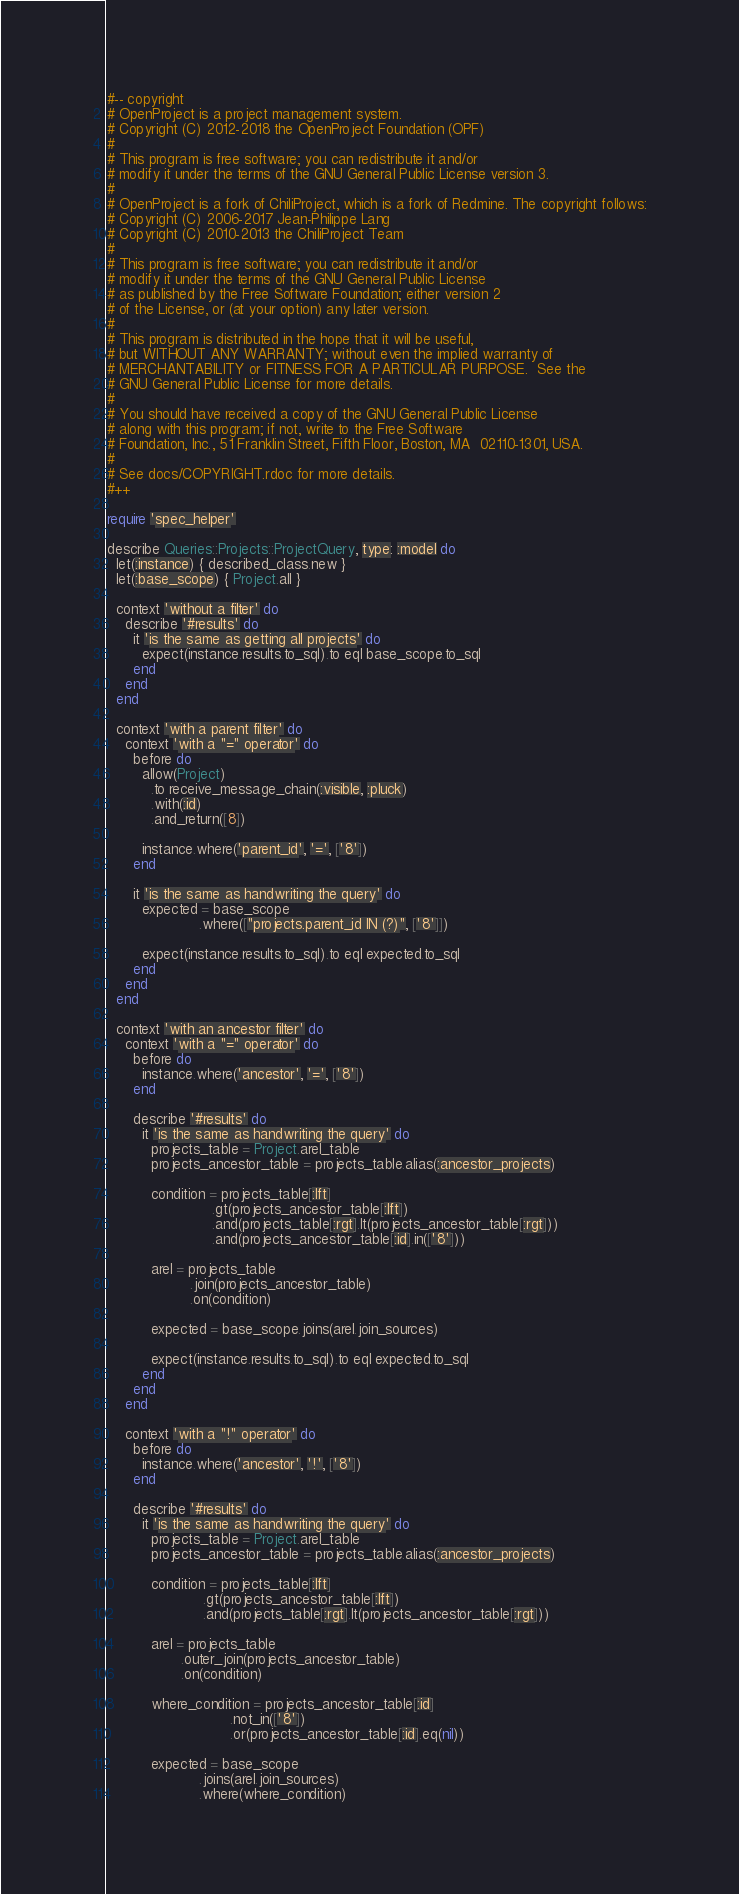Convert code to text. <code><loc_0><loc_0><loc_500><loc_500><_Ruby_>#-- copyright
# OpenProject is a project management system.
# Copyright (C) 2012-2018 the OpenProject Foundation (OPF)
#
# This program is free software; you can redistribute it and/or
# modify it under the terms of the GNU General Public License version 3.
#
# OpenProject is a fork of ChiliProject, which is a fork of Redmine. The copyright follows:
# Copyright (C) 2006-2017 Jean-Philippe Lang
# Copyright (C) 2010-2013 the ChiliProject Team
#
# This program is free software; you can redistribute it and/or
# modify it under the terms of the GNU General Public License
# as published by the Free Software Foundation; either version 2
# of the License, or (at your option) any later version.
#
# This program is distributed in the hope that it will be useful,
# but WITHOUT ANY WARRANTY; without even the implied warranty of
# MERCHANTABILITY or FITNESS FOR A PARTICULAR PURPOSE.  See the
# GNU General Public License for more details.
#
# You should have received a copy of the GNU General Public License
# along with this program; if not, write to the Free Software
# Foundation, Inc., 51 Franklin Street, Fifth Floor, Boston, MA  02110-1301, USA.
#
# See docs/COPYRIGHT.rdoc for more details.
#++

require 'spec_helper'

describe Queries::Projects::ProjectQuery, type: :model do
  let(:instance) { described_class.new }
  let(:base_scope) { Project.all }

  context 'without a filter' do
    describe '#results' do
      it 'is the same as getting all projects' do
        expect(instance.results.to_sql).to eql base_scope.to_sql
      end
    end
  end

  context 'with a parent filter' do
    context 'with a "=" operator' do
      before do
        allow(Project)
          .to receive_message_chain(:visible, :pluck)
          .with(:id)
          .and_return([8])

        instance.where('parent_id', '=', ['8'])
      end

      it 'is the same as handwriting the query' do
        expected = base_scope
                     .where(["projects.parent_id IN (?)", ['8']])

        expect(instance.results.to_sql).to eql expected.to_sql
      end
    end
  end

  context 'with an ancestor filter' do
    context 'with a "=" operator' do
      before do
        instance.where('ancestor', '=', ['8'])
      end

      describe '#results' do
        it 'is the same as handwriting the query' do
          projects_table = Project.arel_table
          projects_ancestor_table = projects_table.alias(:ancestor_projects)

          condition = projects_table[:lft]
                        .gt(projects_ancestor_table[:lft])
                        .and(projects_table[:rgt].lt(projects_ancestor_table[:rgt]))
                        .and(projects_ancestor_table[:id].in(['8']))

          arel = projects_table
                   .join(projects_ancestor_table)
                   .on(condition)

          expected = base_scope.joins(arel.join_sources)

          expect(instance.results.to_sql).to eql expected.to_sql
        end
      end
    end

    context 'with a "!" operator' do
      before do
        instance.where('ancestor', '!', ['8'])
      end

      describe '#results' do
        it 'is the same as handwriting the query' do
          projects_table = Project.arel_table
          projects_ancestor_table = projects_table.alias(:ancestor_projects)

          condition = projects_table[:lft]
                      .gt(projects_ancestor_table[:lft])
                      .and(projects_table[:rgt].lt(projects_ancestor_table[:rgt]))

          arel = projects_table
                 .outer_join(projects_ancestor_table)
                 .on(condition)

          where_condition = projects_ancestor_table[:id]
                            .not_in(['8'])
                            .or(projects_ancestor_table[:id].eq(nil))

          expected = base_scope
                     .joins(arel.join_sources)
                     .where(where_condition)
</code> 